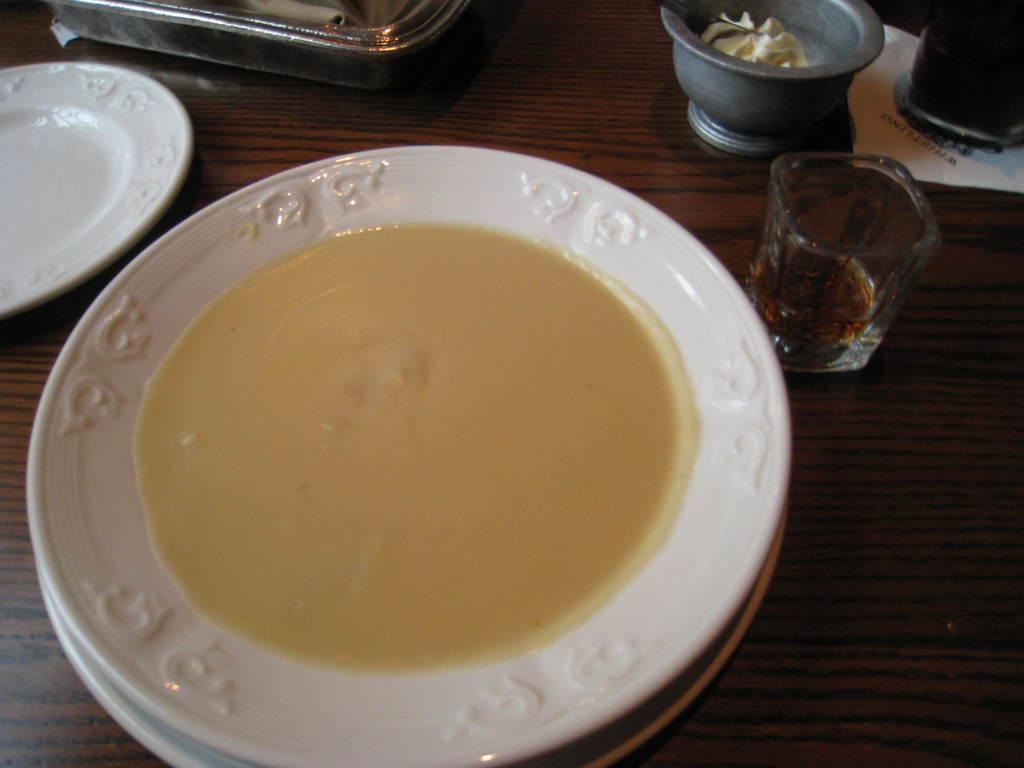Please provide a concise description of this image. In this image we can see a table. On the table there are serving plate with sauce in it, glass tumbler with beverage in it, a bowl with cream in it. 